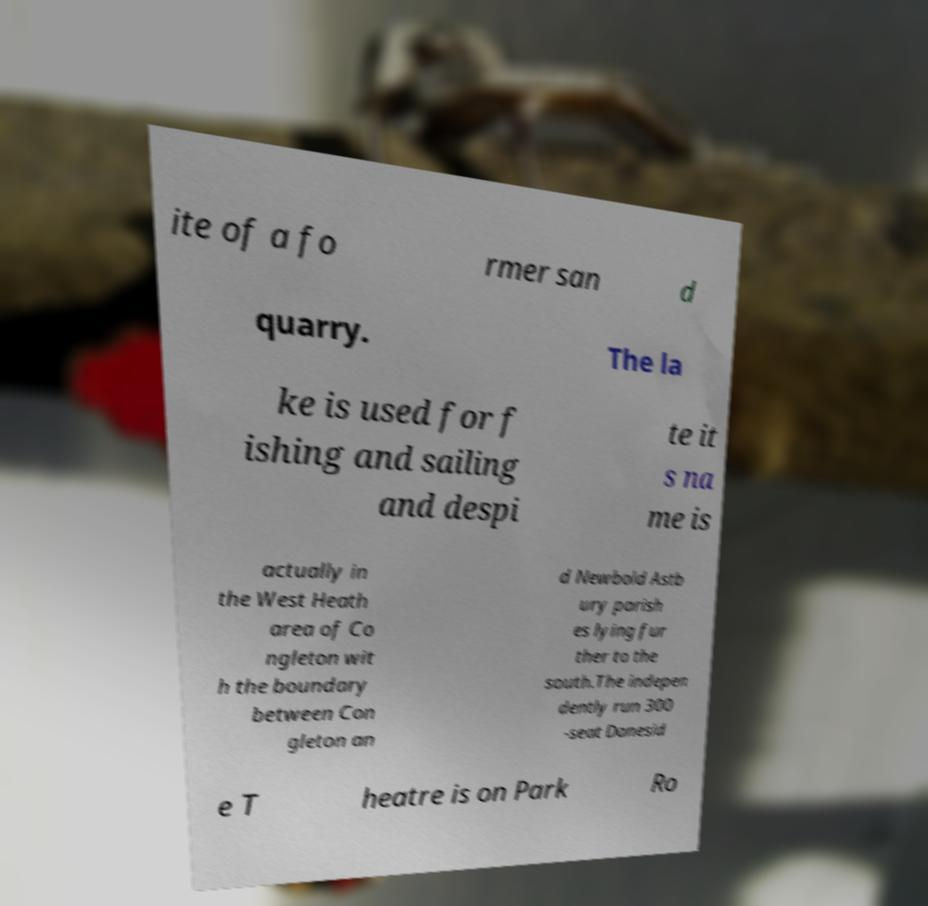Can you accurately transcribe the text from the provided image for me? ite of a fo rmer san d quarry. The la ke is used for f ishing and sailing and despi te it s na me is actually in the West Heath area of Co ngleton wit h the boundary between Con gleton an d Newbold Astb ury parish es lying fur ther to the south.The indepen dently run 300 -seat Danesid e T heatre is on Park Ro 